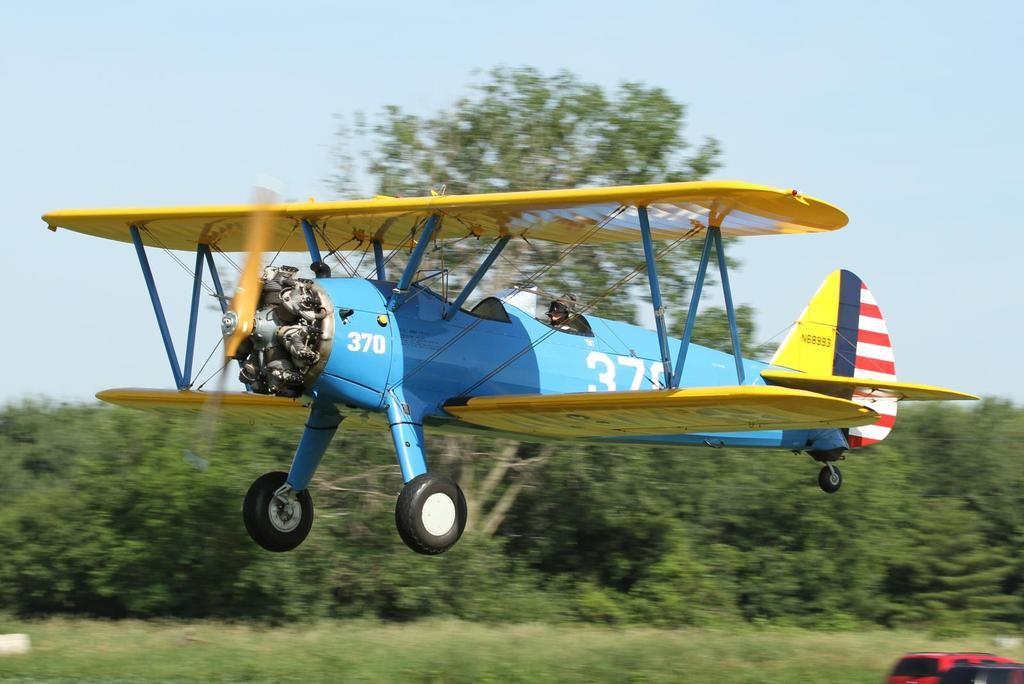Provide a one-sentence caption for the provided image. a small single engine blue plane numbered 370 either landing or taking off. 